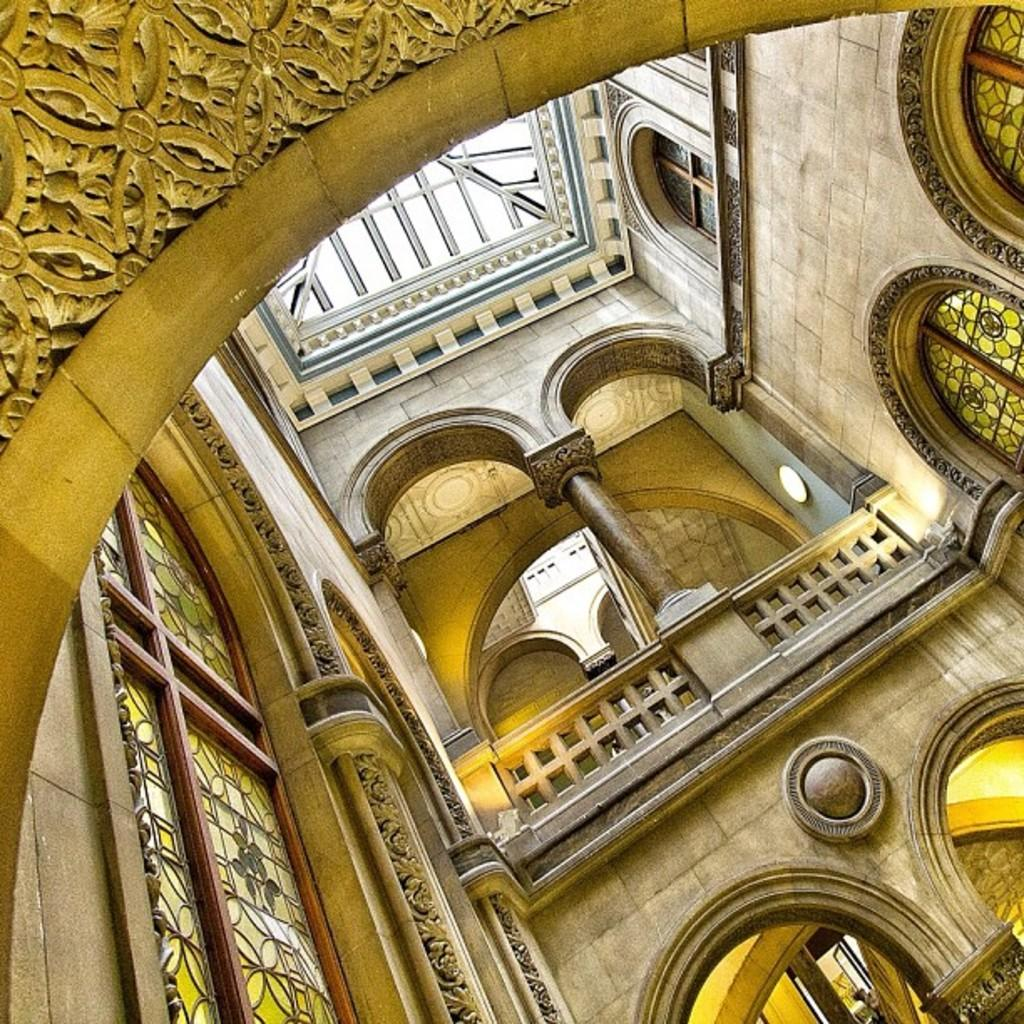What type of space is depicted in the image? The image shows an interior view of a building. What architectural features can be seen in the image? There are arches, pillars, and walls visible in the image. What type of barrier is present in the image? There is a fence in the image. What type of windows are present in the image? There are glass windows in the image. What additional structure can be seen in the image? There is a shed in the image. What route does the ink take to travel through the building in the image? There is no ink present in the image, so it cannot be determined how it would travel through the building. 